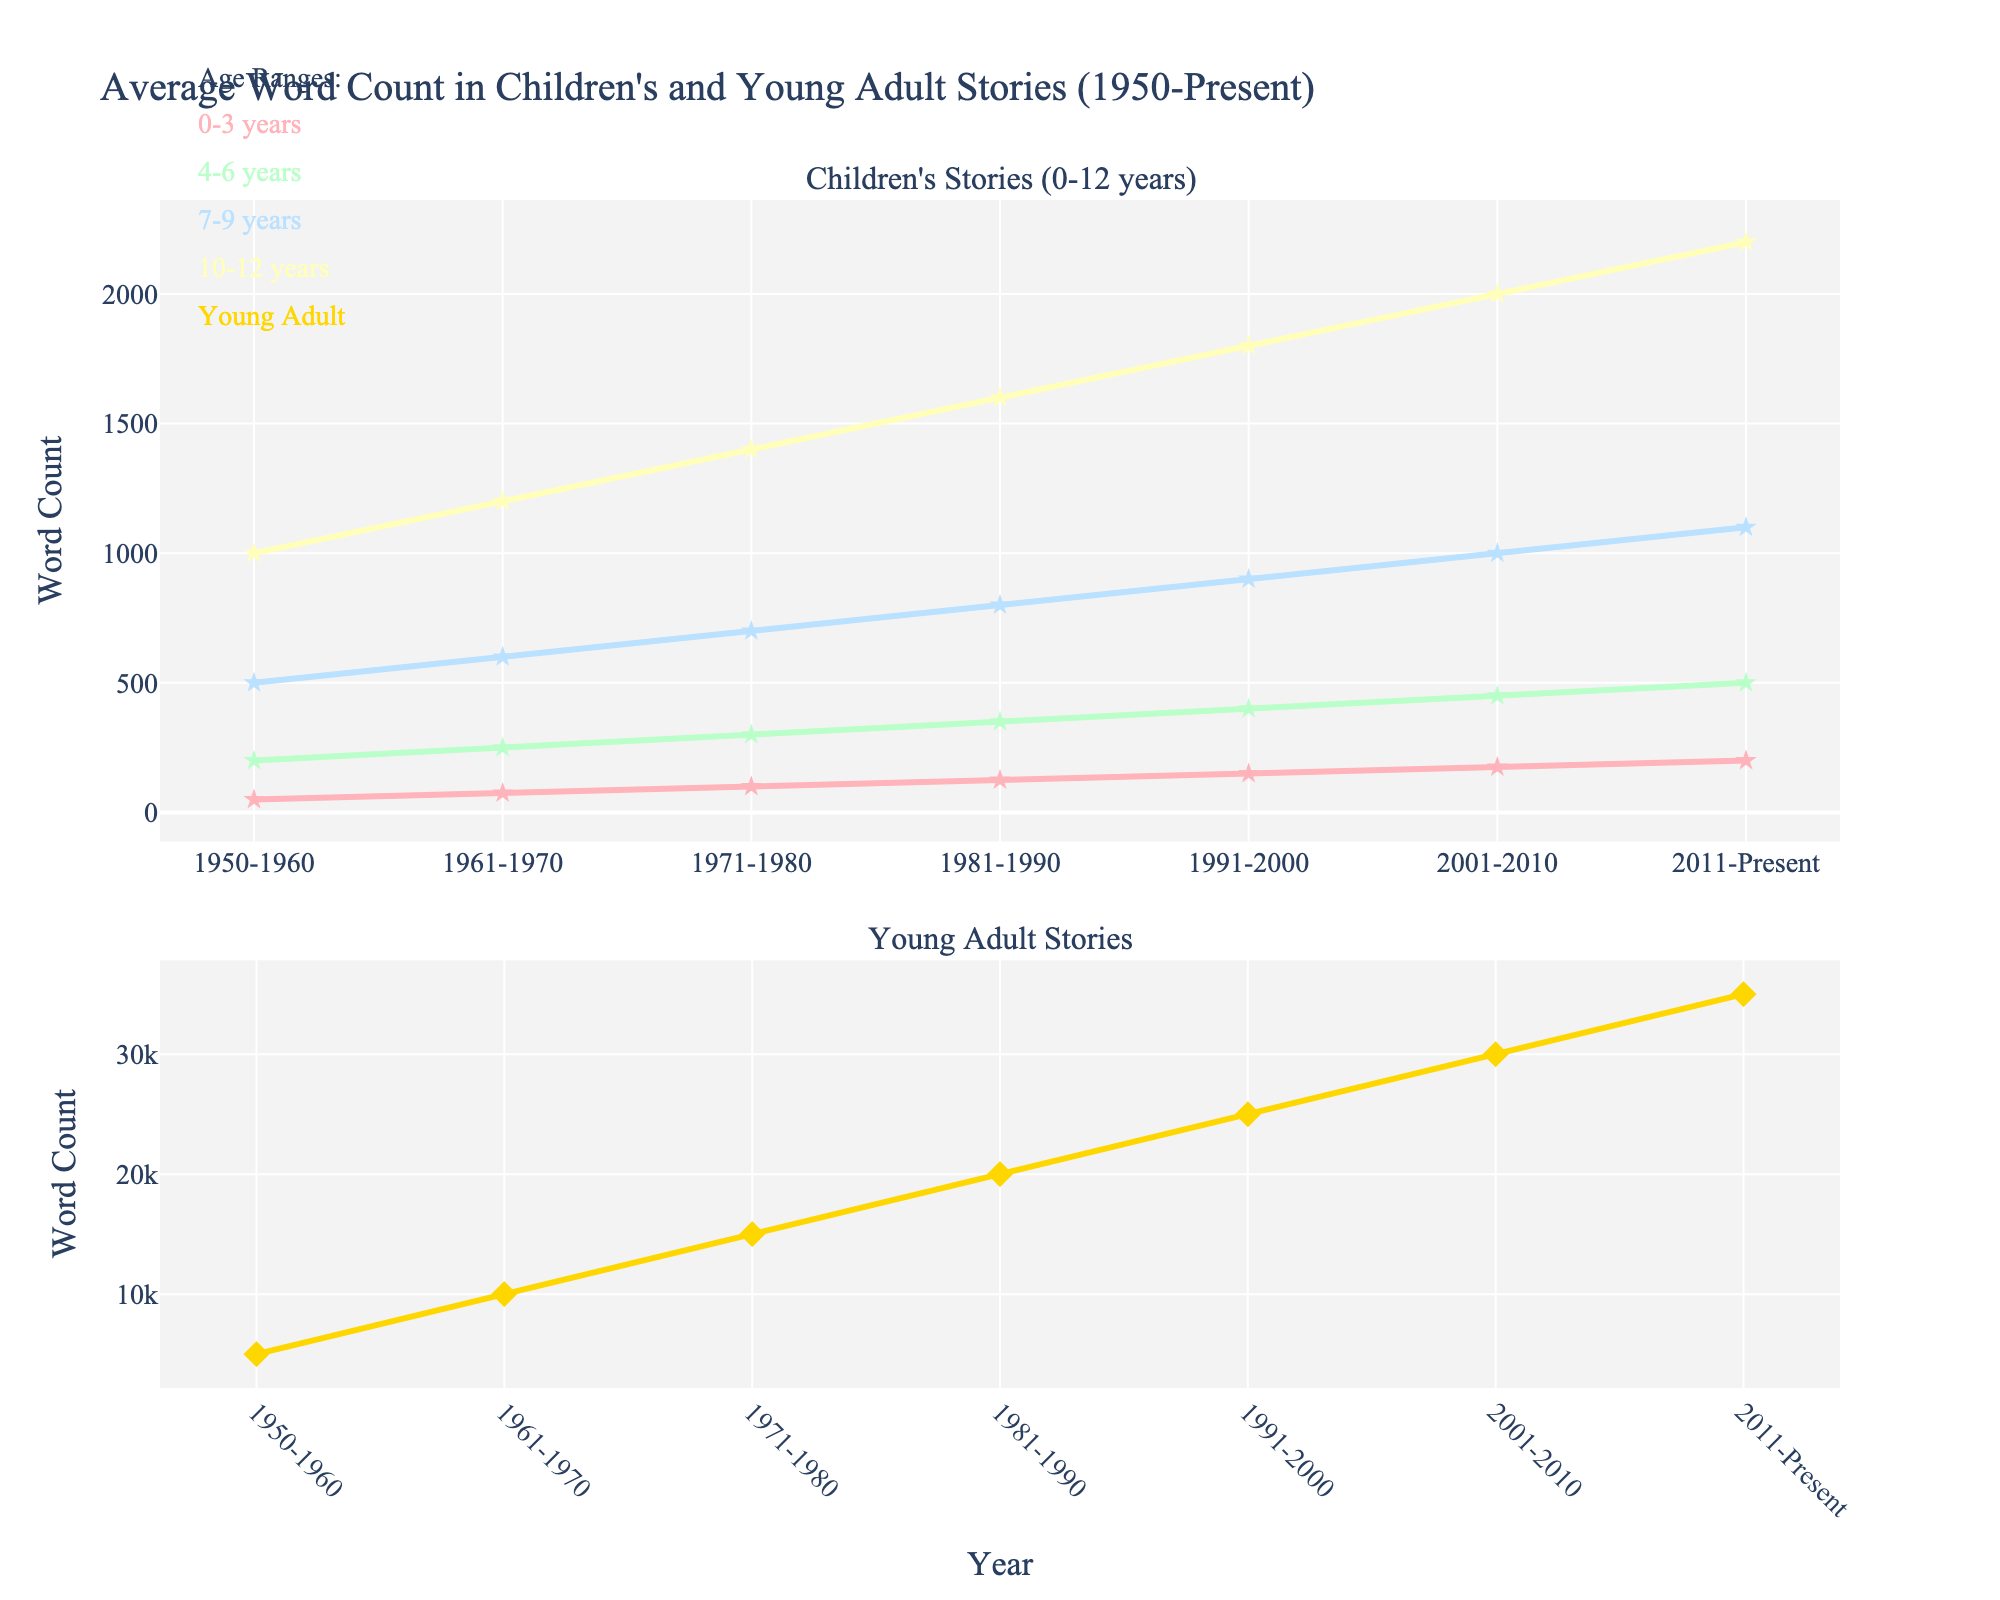What is the average word count for stories for 4-6 years in the 1981-1990 period? Look at the point corresponding to the 4-6 years age range and the 1981-1990 period, it shows a word count of 350.
Answer: 350 Which age range had the highest increase in word count from 1950 to present? Identify the initial and final word counts for each age range: 0-3 years (50 to 200), 4-6 years (200 to 500), 7-9 years (500 to 1100), 10-12 years (1000 to 2200), Young Adult (5000 to 35000). Calculate the increase for each range. Young Adult had the highest increase (30000 words).
Answer: Young Adult How does the word count for 7-9 years in the 1971-1980 period compare to the word count for 10-12 years in the same period? Check the points for both age ranges in the 1971-1980 period: 7-9 years had a word count of 700; 10-12 years had a word count of 1400. The latter is twice the former.
Answer: 10-12 years is twice 7-9 years Which age range shows the steepest increase in the 1991-2000 period? Compare the slopes of the lines (rise over run) in the 1991-2000 period for each age range. Young Adult shows the steepest increase as its word count went from 25000 to 30000.
Answer: Young Adult In which period did the word count for stories for 0-3 years old surpass 100 words for the first time? Look for the first period in which the 0-3 years old line passes 100 words: This occurs in the period 1971-1980.
Answer: 1971-1980 What is the difference in word count for 4-6 years stories between the periods 1950-1960 and 2011-Present? Subtract the word count for 1950-1960 (200) from the word count for 2011-Present (500), the difference is 300.
Answer: 300 Compare the word count trend of 0-3 years stories to 7-9 years stories over the entire period. 0-3 years stories have a word count that increases steadily from 50 to 200, whereas 7-9 years stories increase from 500 to 1100, showing a steeper overall progression.
Answer: 7-9 years increase more steeply What was the word count for Young Adult stories in the 1961-1970 period and how much did it increase by 2011-Present? The word count for Young Adult stories in the 1961-1970 period is 10000, and in 2011-Present, it is 35000. The increase is 35000 - 10000 = 25000.
Answer: Increased by 25000 Which age range had the least word count in the 2001-2010 period? Compare the word counts of all age ranges in 2001-2010. The 0-3 years age range had the least word count at 175.
Answer: 0-3 years 